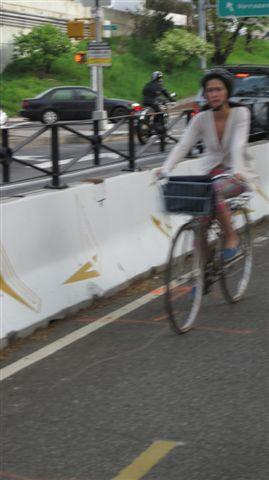How is the women moving? cycling 